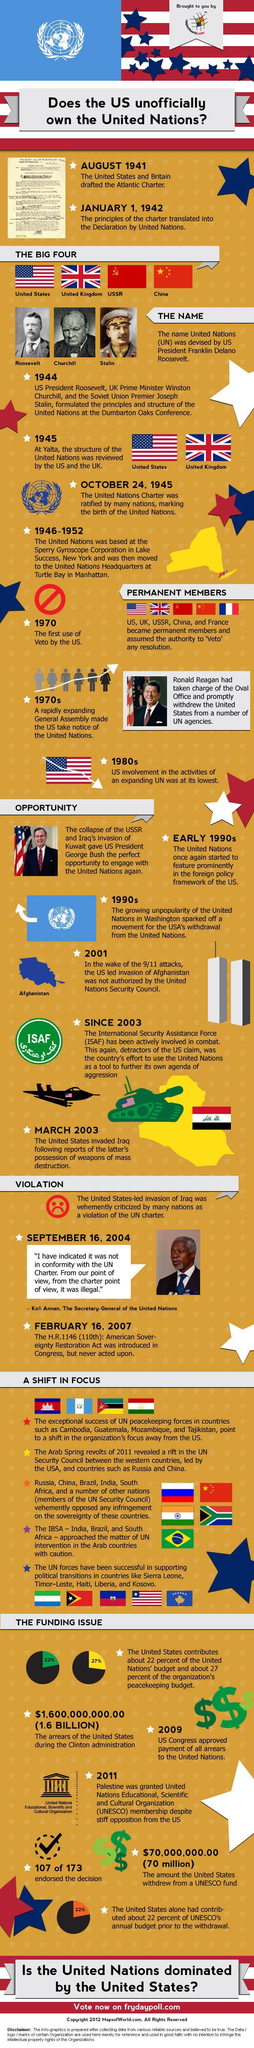In how many countries have the UN peace keeping forces played a significant role?
Answer the question with a short phrase. 4 Which US President was involved in the ideation of the UN, George Bush, Ronald Reagan, or Franklin Roosevelt? Franklin Roosevelt How many countries are a part of IBSA? 3 Which country was the first to exercise veto power? US During which time periods did US decide to withdraw from UN? 1970s, 1990s 